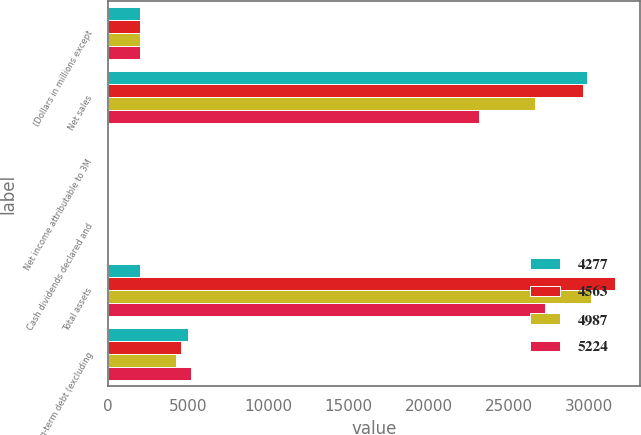<chart> <loc_0><loc_0><loc_500><loc_500><stacked_bar_chart><ecel><fcel>(Dollars in millions except<fcel>Net sales<fcel>Net income attributable to 3M<fcel>Cash dividends declared and<fcel>Total assets<fcel>Long-term debt (excluding<nl><fcel>4277<fcel>2012<fcel>29904<fcel>6.32<fcel>2.36<fcel>2012<fcel>4987<nl><fcel>4563<fcel>2011<fcel>29611<fcel>5.96<fcel>2.2<fcel>31616<fcel>4563<nl><fcel>4987<fcel>2010<fcel>26662<fcel>5.63<fcel>2.1<fcel>30156<fcel>4277<nl><fcel>5224<fcel>2009<fcel>23123<fcel>4.52<fcel>2.04<fcel>27250<fcel>5204<nl></chart> 